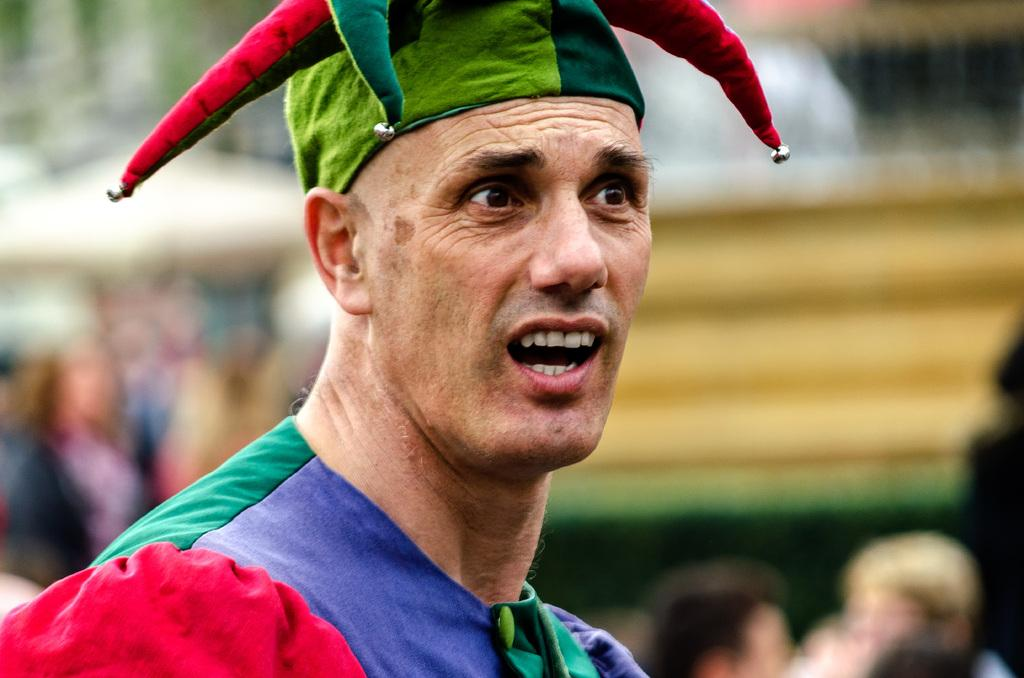What can be seen in the image? There is a person in the image. Can you describe the person's clothing? The person is wearing a cap and a dress with different colors. What is the person doing in the image? The person is speaking. How would you describe the background of the image? The background of the image is blurred. How many brothers does the person in the image have? There is no information about the person's siblings in the image. 